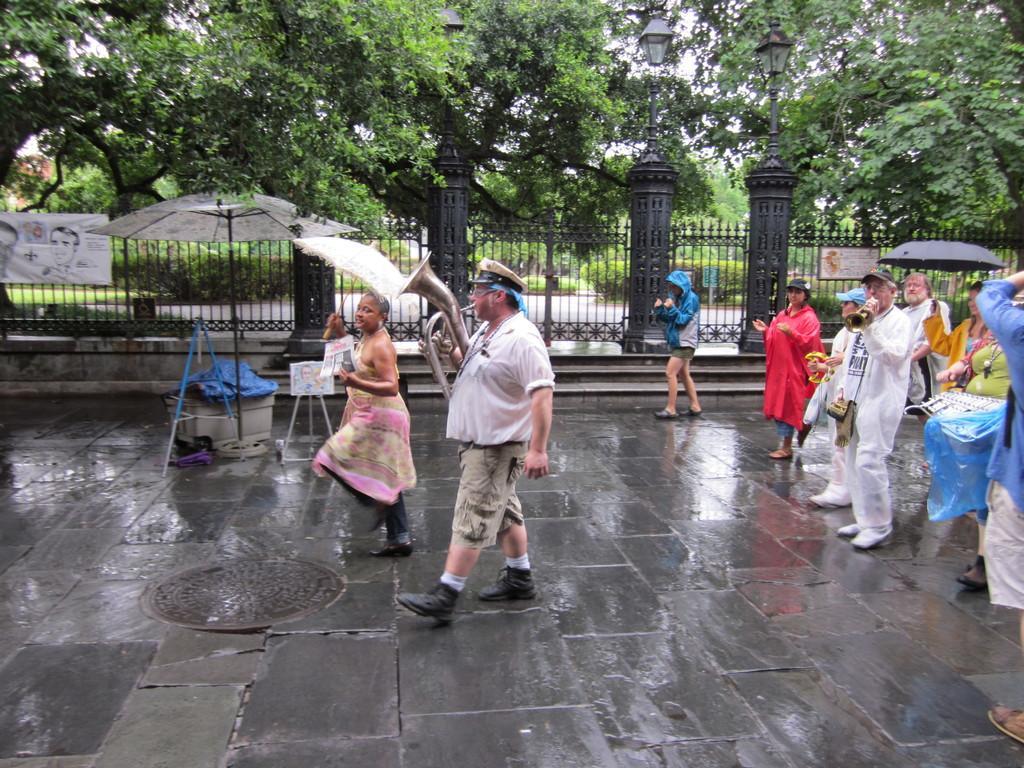Please provide a concise description of this image. In this image we can see a person is walking and playing some musical instrument. He is wearing white shirt with shorts. Beside one lady is dancing by holding umbrella in her hand. Right side of the image people are standing and few people are playing music. Background of the image grille is present with light pillars and trees are there. Left side of the image one umbrella, under the umbrella some things are there. 